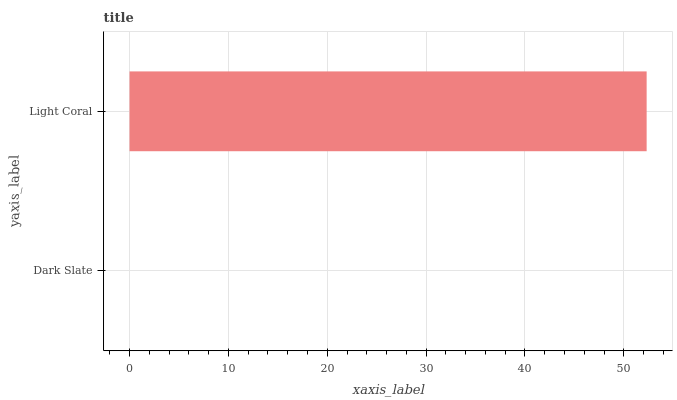Is Dark Slate the minimum?
Answer yes or no. Yes. Is Light Coral the maximum?
Answer yes or no. Yes. Is Light Coral the minimum?
Answer yes or no. No. Is Light Coral greater than Dark Slate?
Answer yes or no. Yes. Is Dark Slate less than Light Coral?
Answer yes or no. Yes. Is Dark Slate greater than Light Coral?
Answer yes or no. No. Is Light Coral less than Dark Slate?
Answer yes or no. No. Is Light Coral the high median?
Answer yes or no. Yes. Is Dark Slate the low median?
Answer yes or no. Yes. Is Dark Slate the high median?
Answer yes or no. No. Is Light Coral the low median?
Answer yes or no. No. 